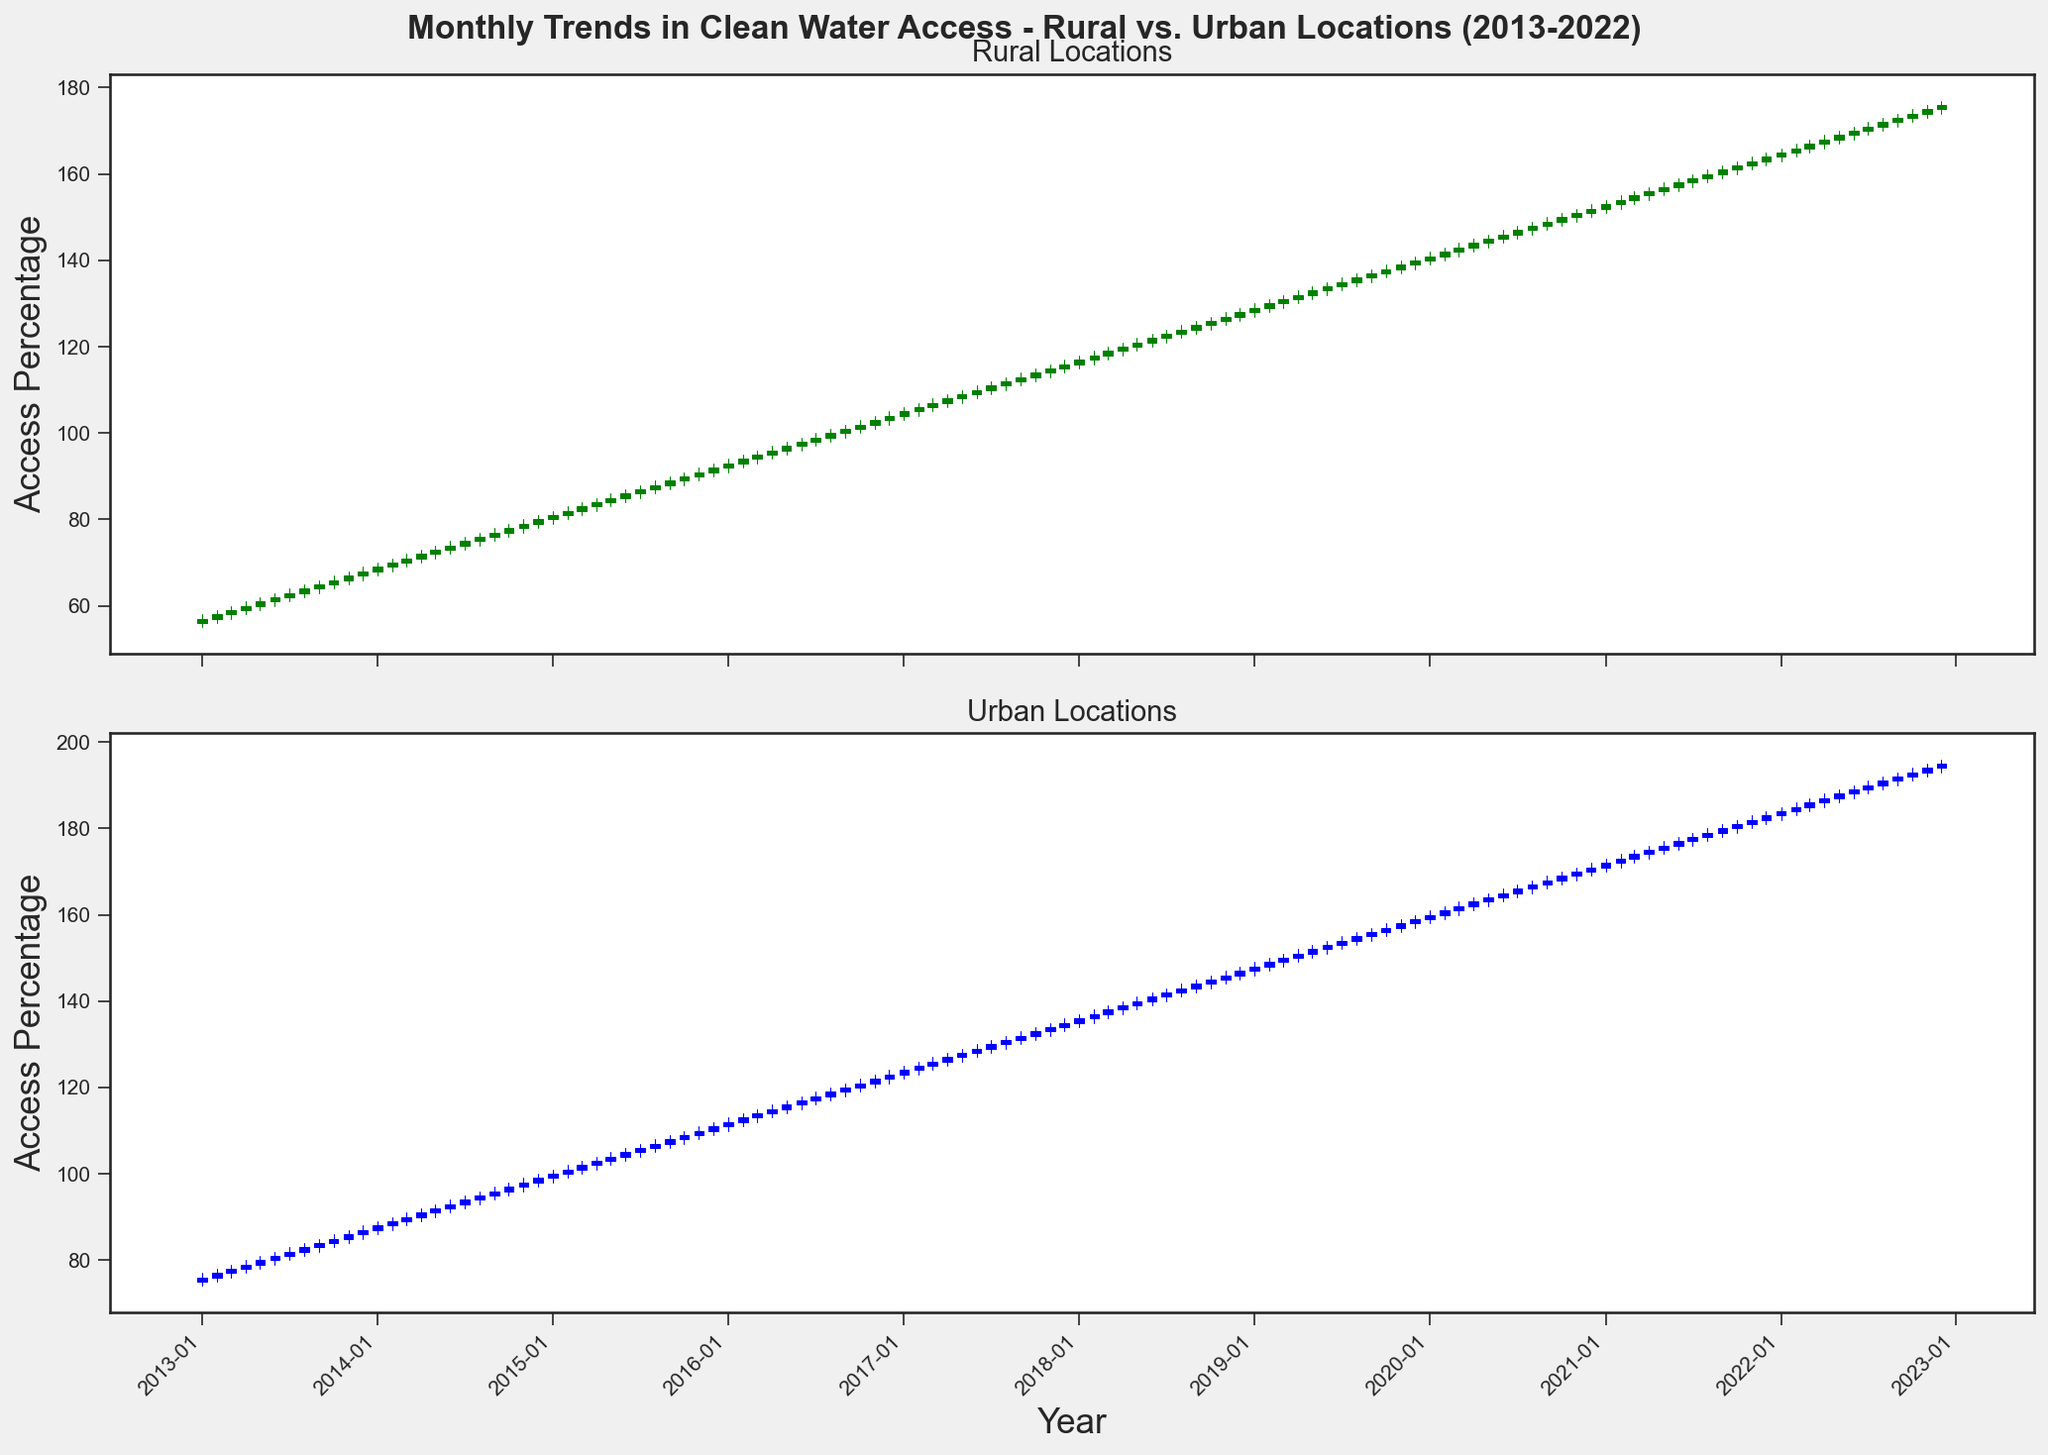What are the access percentage trends for rural and urban locations over the decade? Observing the candlesticks, both rural and urban locations show a consistent upward trend in clean water access. Rural access starts around 57% in January 2013 and steadily climbs to about 176% by December 2022. Similarly, urban access starts around 76% in January 2013 and rises to approximately 195% by December 2022.
Answer: Both rural and urban locations show an increasing trend Which locations had a greater increase in water access over the decade? By examining the starting and ending values of the candlestick charts, rural locations increased from an access close of 57% to 176% (an increase of 119 percentage points), while urban locations increased from 76% to 195% (an increase of 119 percentage points). Thus, both have an identical increase in absolute terms, but urban locations can be considered more significant due to the higher baseline.
Answer: Urban locations What is the difference in the maximum water access percentage between urban and rural locations in December 2022? Looking at the highest points of the candlesticks for December 2022, rural locations reach a high of 177% while urban locations reach a high of 196%. The difference would be 196% - 177% = 19%.
Answer: 19% What month and year did rural locations first cross 100% water access? By following the rural candlestick chart, the first month where the closing value crosses the 100% mark appears to be January 2016.
Answer: January 2016 Which locations experienced more significant fluctuations in access percentages? By comparing the candlestick sizes, urban locations show slightly more significant fluctuations (distance between high and low points of the candlesticks) compared to rural locations. This indicates that the urban values experienced more variability.
Answer: Urban locations During which month did urban locations show the highest access percentage in the past decade? Reviewing the uppermost point of the urban candlestick chart, we can see that it occurs in December 2022.
Answer: December 2022 How consistent are rural locations' monthly increments compared to urban locations? The rural candlestick chart displays more uniform and consistent monthly increments, while urban locations have larger and more variable monthly increments. This can be interpreted from the narrower and more uniform candlestick body lengths in the rural chart.
Answer: Rural locations have more consistent increments Compare the water access percentages for rural and urban locations in January 2018? The rural location candlestick in January 2018 shows a close value of 117%, while the urban location candlestick shows a close value of 136%. Therefore, urban locations had a higher water access percentage in January 2018.
Answer: Urban locations What is the trend in the differences between rural and urban water access starting from 2013 to 2022? Starting from a noticeable gap in January 2013 when urban access was higher by 19 percentage points (76% vs. 57%), the difference between urban and rural access closes over time but remains relatively stable around 20 percentage points by December 2022 (195% vs. 176%).
Answer: The difference remains relatively stable around 20 percentage points In which year did rural water access percentage first exceed urban's lowest value? Looking at when the monthly closing value of rural access first surpasses urban's minimum values, it occurs in January 2020 when rural access hits 141%, higher than urban's lowest point in December 2018 of 145%. Thus, rural exceeded urban's lowest access value before 2020.
Answer: January 2020 